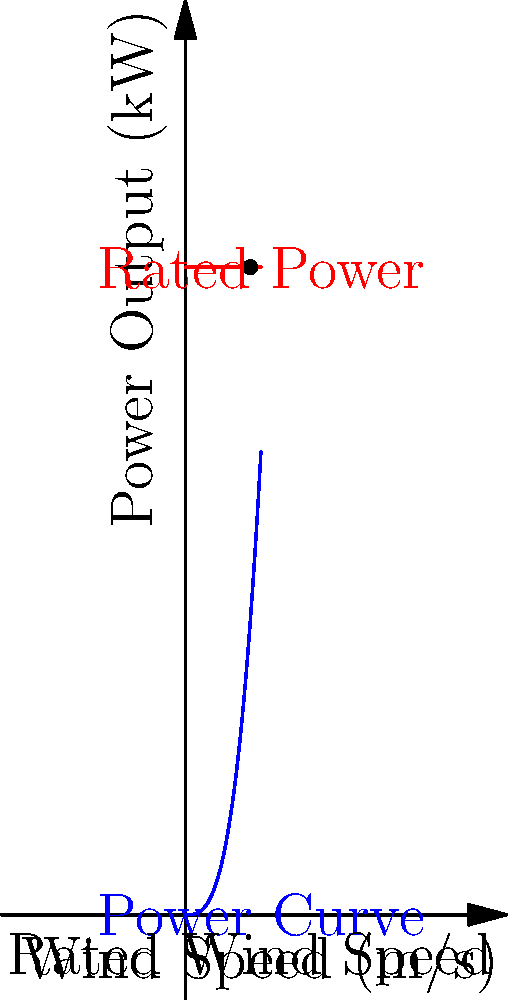As an expert in renewable energy law, you're reviewing a case involving a wind turbine design. The power output (P) of a wind turbine is given by the equation:

$$ P = \frac{1}{2} \rho A C_p v^3 $$

Where $\rho$ is air density (1.225 kg/m³), A is swept area, $C_p$ is power coefficient (0.4), and v is wind speed. The turbine has a blade length of 25 meters and reaches its rated power of 30 kW at a wind speed of 3 m/s.

Using the given power curve, calculate the swept area of the turbine blades to determine if it complies with the design specifications. Let's approach this step-by-step:

1) The swept area A is the area of the circle traced by the turbine blades. For a blade length (radius) r, it's given by:
   $$ A = \pi r^2 = \pi (25 \text{ m})^2 = 1963.5 \text{ m}^2 $$

2) We're told that the rated power of 30 kW is reached at 3 m/s. Let's use the power equation at this point:
   $$ 30,000 \text{ W} = \frac{1}{2} (1.225 \text{ kg/m}^3) (A) (0.4) (3 \text{ m/s})^3 $$

3) Solve for A:
   $$ A = \frac{2 (30,000 \text{ W})}{(1.225 \text{ kg/m}^3) (0.4) (3 \text{ m/s})^3} = 1359.7 \text{ m}^2 $$

4) Compare this to the swept area we calculated in step 1:
   1963.5 m² > 1359.7 m²

5) The actual swept area is larger than required, which means the turbine can potentially generate more power than its rated capacity at the given wind speed.

This design provides a safety margin and ensures the turbine can reach its rated power even in slightly less favorable conditions, which is a common practice in wind turbine engineering.
Answer: The turbine complies with and exceeds design specifications, with an actual swept area of 1963.5 m² compared to the required 1359.7 m². 